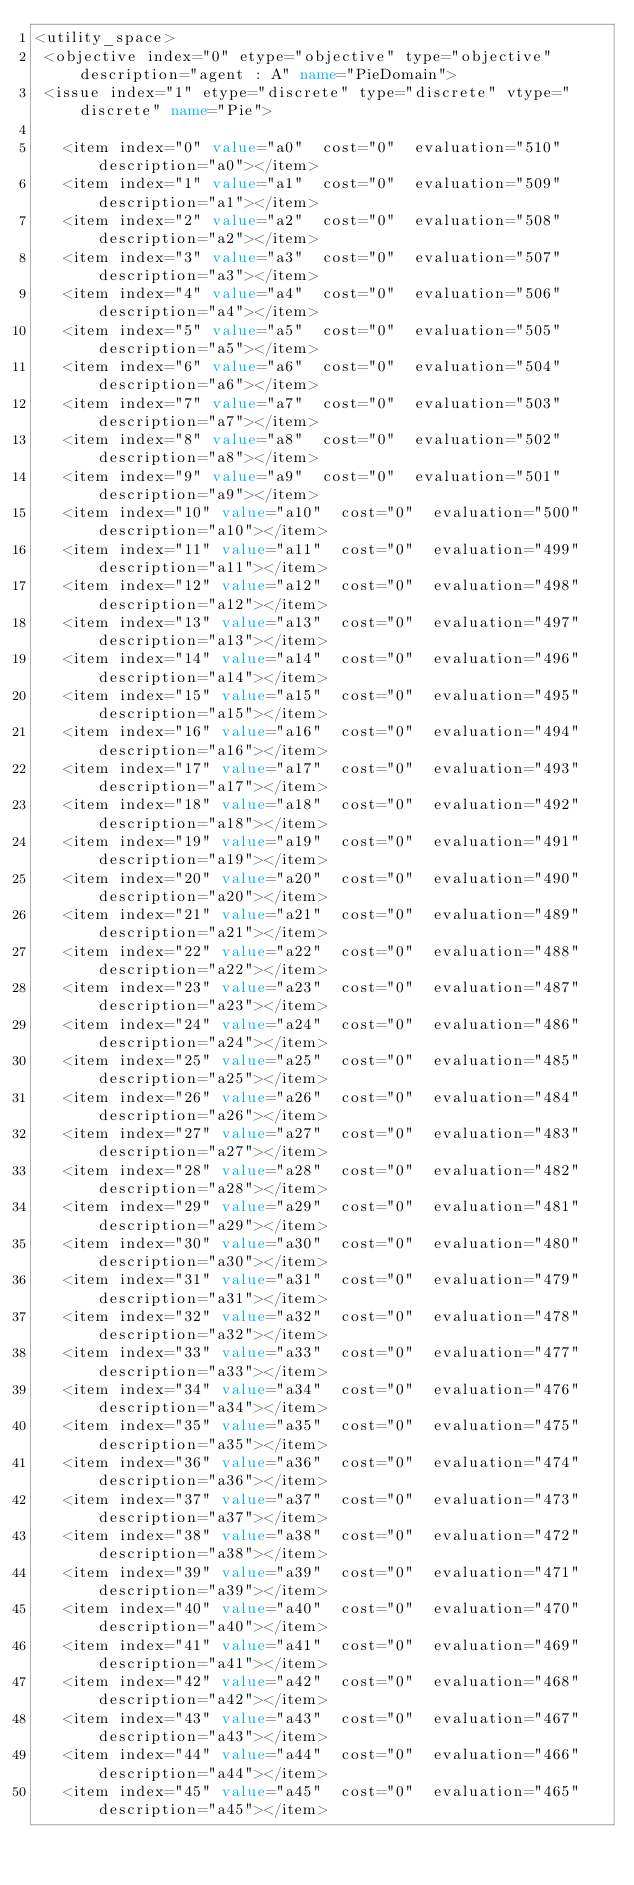Convert code to text. <code><loc_0><loc_0><loc_500><loc_500><_XML_><utility_space>
 <objective index="0" etype="objective" type="objective" description="agent : A" name="PieDomain">
 <issue index="1" etype="discrete" type="discrete" vtype="discrete" name="Pie">

	 <item index="0" value="a0"  cost="0"  evaluation="510" description="a0"></item>
	 <item index="1" value="a1"  cost="0"  evaluation="509" description="a1"></item>
	 <item index="2" value="a2"  cost="0"  evaluation="508" description="a2"></item>
	 <item index="3" value="a3"  cost="0"  evaluation="507" description="a3"></item>
	 <item index="4" value="a4"  cost="0"  evaluation="506" description="a4"></item>
	 <item index="5" value="a5"  cost="0"  evaluation="505" description="a5"></item>
	 <item index="6" value="a6"  cost="0"  evaluation="504" description="a6"></item>
	 <item index="7" value="a7"  cost="0"  evaluation="503" description="a7"></item>
	 <item index="8" value="a8"  cost="0"  evaluation="502" description="a8"></item>
	 <item index="9" value="a9"  cost="0"  evaluation="501" description="a9"></item>
	 <item index="10" value="a10"  cost="0"  evaluation="500" description="a10"></item>
	 <item index="11" value="a11"  cost="0"  evaluation="499" description="a11"></item>
	 <item index="12" value="a12"  cost="0"  evaluation="498" description="a12"></item>
	 <item index="13" value="a13"  cost="0"  evaluation="497" description="a13"></item>
	 <item index="14" value="a14"  cost="0"  evaluation="496" description="a14"></item>
	 <item index="15" value="a15"  cost="0"  evaluation="495" description="a15"></item>
	 <item index="16" value="a16"  cost="0"  evaluation="494" description="a16"></item>
	 <item index="17" value="a17"  cost="0"  evaluation="493" description="a17"></item>
	 <item index="18" value="a18"  cost="0"  evaluation="492" description="a18"></item>
	 <item index="19" value="a19"  cost="0"  evaluation="491" description="a19"></item>
	 <item index="20" value="a20"  cost="0"  evaluation="490" description="a20"></item>
	 <item index="21" value="a21"  cost="0"  evaluation="489" description="a21"></item>
	 <item index="22" value="a22"  cost="0"  evaluation="488" description="a22"></item>
	 <item index="23" value="a23"  cost="0"  evaluation="487" description="a23"></item>
	 <item index="24" value="a24"  cost="0"  evaluation="486" description="a24"></item>
	 <item index="25" value="a25"  cost="0"  evaluation="485" description="a25"></item>
	 <item index="26" value="a26"  cost="0"  evaluation="484" description="a26"></item>
	 <item index="27" value="a27"  cost="0"  evaluation="483" description="a27"></item>
	 <item index="28" value="a28"  cost="0"  evaluation="482" description="a28"></item>
	 <item index="29" value="a29"  cost="0"  evaluation="481" description="a29"></item>
	 <item index="30" value="a30"  cost="0"  evaluation="480" description="a30"></item>
	 <item index="31" value="a31"  cost="0"  evaluation="479" description="a31"></item>
	 <item index="32" value="a32"  cost="0"  evaluation="478" description="a32"></item>
	 <item index="33" value="a33"  cost="0"  evaluation="477" description="a33"></item>
	 <item index="34" value="a34"  cost="0"  evaluation="476" description="a34"></item>
	 <item index="35" value="a35"  cost="0"  evaluation="475" description="a35"></item>
	 <item index="36" value="a36"  cost="0"  evaluation="474" description="a36"></item>
	 <item index="37" value="a37"  cost="0"  evaluation="473" description="a37"></item>
	 <item index="38" value="a38"  cost="0"  evaluation="472" description="a38"></item>
	 <item index="39" value="a39"  cost="0"  evaluation="471" description="a39"></item>
	 <item index="40" value="a40"  cost="0"  evaluation="470" description="a40"></item>
	 <item index="41" value="a41"  cost="0"  evaluation="469" description="a41"></item>
	 <item index="42" value="a42"  cost="0"  evaluation="468" description="a42"></item>
	 <item index="43" value="a43"  cost="0"  evaluation="467" description="a43"></item>
	 <item index="44" value="a44"  cost="0"  evaluation="466" description="a44"></item>
	 <item index="45" value="a45"  cost="0"  evaluation="465" description="a45"></item></code> 